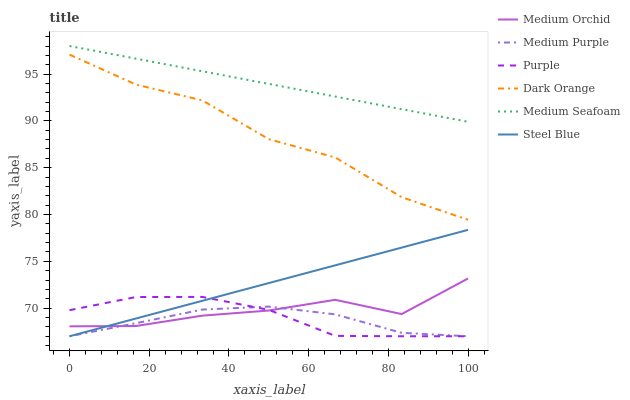Does Medium Purple have the minimum area under the curve?
Answer yes or no. Yes. Does Medium Seafoam have the maximum area under the curve?
Answer yes or no. Yes. Does Purple have the minimum area under the curve?
Answer yes or no. No. Does Purple have the maximum area under the curve?
Answer yes or no. No. Is Steel Blue the smoothest?
Answer yes or no. Yes. Is Dark Orange the roughest?
Answer yes or no. Yes. Is Purple the smoothest?
Answer yes or no. No. Is Purple the roughest?
Answer yes or no. No. Does Purple have the lowest value?
Answer yes or no. Yes. Does Medium Orchid have the lowest value?
Answer yes or no. No. Does Medium Seafoam have the highest value?
Answer yes or no. Yes. Does Purple have the highest value?
Answer yes or no. No. Is Purple less than Dark Orange?
Answer yes or no. Yes. Is Medium Seafoam greater than Medium Purple?
Answer yes or no. Yes. Does Medium Orchid intersect Purple?
Answer yes or no. Yes. Is Medium Orchid less than Purple?
Answer yes or no. No. Is Medium Orchid greater than Purple?
Answer yes or no. No. Does Purple intersect Dark Orange?
Answer yes or no. No. 